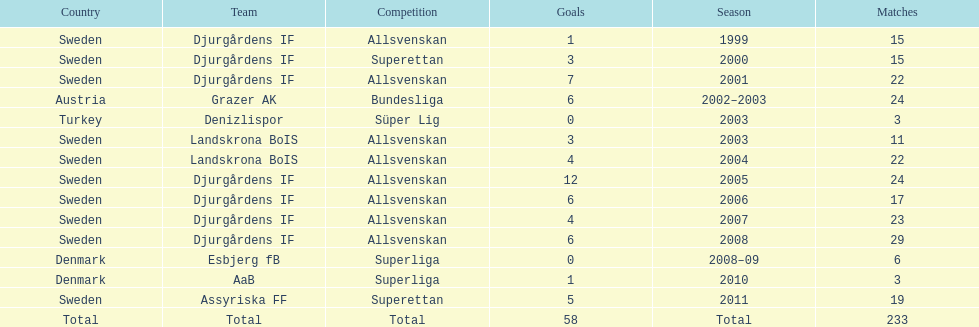How many matches did jones kusi-asare play in in his first season? 15. 